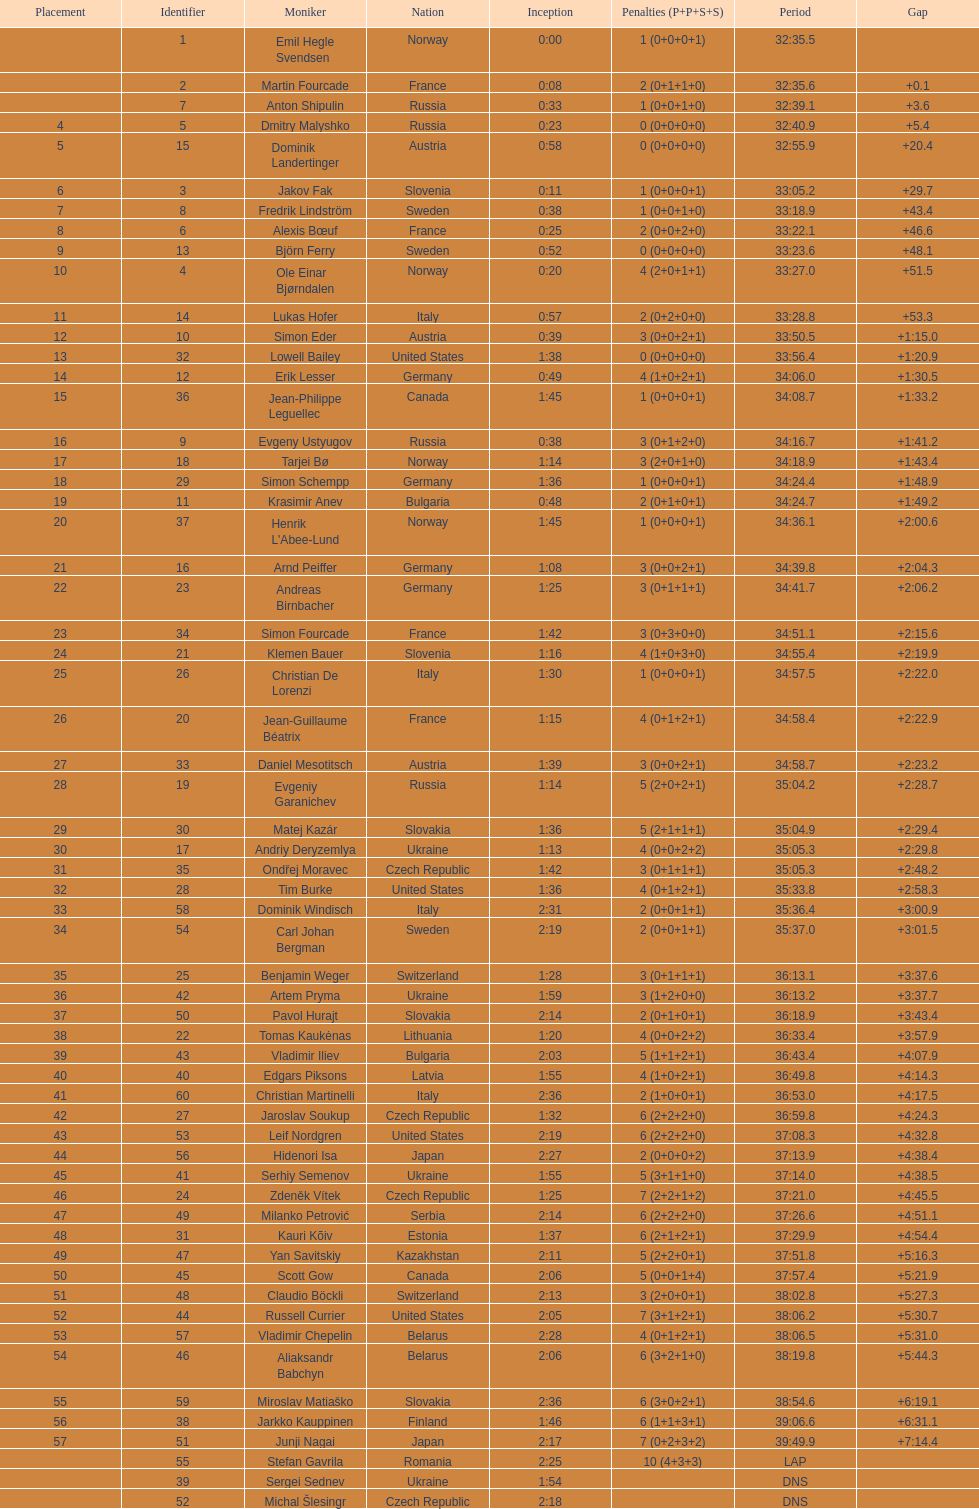Between bjorn ferry, simon elder and erik lesser - who had the most penalties? Erik Lesser. Would you be able to parse every entry in this table? {'header': ['Placement', 'Identifier', 'Moniker', 'Nation', 'Inception', 'Penalties (P+P+S+S)', 'Period', 'Gap'], 'rows': [['', '1', 'Emil Hegle Svendsen', 'Norway', '0:00', '1 (0+0+0+1)', '32:35.5', ''], ['', '2', 'Martin Fourcade', 'France', '0:08', '2 (0+1+1+0)', '32:35.6', '+0.1'], ['', '7', 'Anton Shipulin', 'Russia', '0:33', '1 (0+0+1+0)', '32:39.1', '+3.6'], ['4', '5', 'Dmitry Malyshko', 'Russia', '0:23', '0 (0+0+0+0)', '32:40.9', '+5.4'], ['5', '15', 'Dominik Landertinger', 'Austria', '0:58', '0 (0+0+0+0)', '32:55.9', '+20.4'], ['6', '3', 'Jakov Fak', 'Slovenia', '0:11', '1 (0+0+0+1)', '33:05.2', '+29.7'], ['7', '8', 'Fredrik Lindström', 'Sweden', '0:38', '1 (0+0+1+0)', '33:18.9', '+43.4'], ['8', '6', 'Alexis Bœuf', 'France', '0:25', '2 (0+0+2+0)', '33:22.1', '+46.6'], ['9', '13', 'Björn Ferry', 'Sweden', '0:52', '0 (0+0+0+0)', '33:23.6', '+48.1'], ['10', '4', 'Ole Einar Bjørndalen', 'Norway', '0:20', '4 (2+0+1+1)', '33:27.0', '+51.5'], ['11', '14', 'Lukas Hofer', 'Italy', '0:57', '2 (0+2+0+0)', '33:28.8', '+53.3'], ['12', '10', 'Simon Eder', 'Austria', '0:39', '3 (0+0+2+1)', '33:50.5', '+1:15.0'], ['13', '32', 'Lowell Bailey', 'United States', '1:38', '0 (0+0+0+0)', '33:56.4', '+1:20.9'], ['14', '12', 'Erik Lesser', 'Germany', '0:49', '4 (1+0+2+1)', '34:06.0', '+1:30.5'], ['15', '36', 'Jean-Philippe Leguellec', 'Canada', '1:45', '1 (0+0+0+1)', '34:08.7', '+1:33.2'], ['16', '9', 'Evgeny Ustyugov', 'Russia', '0:38', '3 (0+1+2+0)', '34:16.7', '+1:41.2'], ['17', '18', 'Tarjei Bø', 'Norway', '1:14', '3 (2+0+1+0)', '34:18.9', '+1:43.4'], ['18', '29', 'Simon Schempp', 'Germany', '1:36', '1 (0+0+0+1)', '34:24.4', '+1:48.9'], ['19', '11', 'Krasimir Anev', 'Bulgaria', '0:48', '2 (0+1+0+1)', '34:24.7', '+1:49.2'], ['20', '37', "Henrik L'Abee-Lund", 'Norway', '1:45', '1 (0+0+0+1)', '34:36.1', '+2:00.6'], ['21', '16', 'Arnd Peiffer', 'Germany', '1:08', '3 (0+0+2+1)', '34:39.8', '+2:04.3'], ['22', '23', 'Andreas Birnbacher', 'Germany', '1:25', '3 (0+1+1+1)', '34:41.7', '+2:06.2'], ['23', '34', 'Simon Fourcade', 'France', '1:42', '3 (0+3+0+0)', '34:51.1', '+2:15.6'], ['24', '21', 'Klemen Bauer', 'Slovenia', '1:16', '4 (1+0+3+0)', '34:55.4', '+2:19.9'], ['25', '26', 'Christian De Lorenzi', 'Italy', '1:30', '1 (0+0+0+1)', '34:57.5', '+2:22.0'], ['26', '20', 'Jean-Guillaume Béatrix', 'France', '1:15', '4 (0+1+2+1)', '34:58.4', '+2:22.9'], ['27', '33', 'Daniel Mesotitsch', 'Austria', '1:39', '3 (0+0+2+1)', '34:58.7', '+2:23.2'], ['28', '19', 'Evgeniy Garanichev', 'Russia', '1:14', '5 (2+0+2+1)', '35:04.2', '+2:28.7'], ['29', '30', 'Matej Kazár', 'Slovakia', '1:36', '5 (2+1+1+1)', '35:04.9', '+2:29.4'], ['30', '17', 'Andriy Deryzemlya', 'Ukraine', '1:13', '4 (0+0+2+2)', '35:05.3', '+2:29.8'], ['31', '35', 'Ondřej Moravec', 'Czech Republic', '1:42', '3 (0+1+1+1)', '35:05.3', '+2:48.2'], ['32', '28', 'Tim Burke', 'United States', '1:36', '4 (0+1+2+1)', '35:33.8', '+2:58.3'], ['33', '58', 'Dominik Windisch', 'Italy', '2:31', '2 (0+0+1+1)', '35:36.4', '+3:00.9'], ['34', '54', 'Carl Johan Bergman', 'Sweden', '2:19', '2 (0+0+1+1)', '35:37.0', '+3:01.5'], ['35', '25', 'Benjamin Weger', 'Switzerland', '1:28', '3 (0+1+1+1)', '36:13.1', '+3:37.6'], ['36', '42', 'Artem Pryma', 'Ukraine', '1:59', '3 (1+2+0+0)', '36:13.2', '+3:37.7'], ['37', '50', 'Pavol Hurajt', 'Slovakia', '2:14', '2 (0+1+0+1)', '36:18.9', '+3:43.4'], ['38', '22', 'Tomas Kaukėnas', 'Lithuania', '1:20', '4 (0+0+2+2)', '36:33.4', '+3:57.9'], ['39', '43', 'Vladimir Iliev', 'Bulgaria', '2:03', '5 (1+1+2+1)', '36:43.4', '+4:07.9'], ['40', '40', 'Edgars Piksons', 'Latvia', '1:55', '4 (1+0+2+1)', '36:49.8', '+4:14.3'], ['41', '60', 'Christian Martinelli', 'Italy', '2:36', '2 (1+0+0+1)', '36:53.0', '+4:17.5'], ['42', '27', 'Jaroslav Soukup', 'Czech Republic', '1:32', '6 (2+2+2+0)', '36:59.8', '+4:24.3'], ['43', '53', 'Leif Nordgren', 'United States', '2:19', '6 (2+2+2+0)', '37:08.3', '+4:32.8'], ['44', '56', 'Hidenori Isa', 'Japan', '2:27', '2 (0+0+0+2)', '37:13.9', '+4:38.4'], ['45', '41', 'Serhiy Semenov', 'Ukraine', '1:55', '5 (3+1+1+0)', '37:14.0', '+4:38.5'], ['46', '24', 'Zdeněk Vítek', 'Czech Republic', '1:25', '7 (2+2+1+2)', '37:21.0', '+4:45.5'], ['47', '49', 'Milanko Petrović', 'Serbia', '2:14', '6 (2+2+2+0)', '37:26.6', '+4:51.1'], ['48', '31', 'Kauri Kõiv', 'Estonia', '1:37', '6 (2+1+2+1)', '37:29.9', '+4:54.4'], ['49', '47', 'Yan Savitskiy', 'Kazakhstan', '2:11', '5 (2+2+0+1)', '37:51.8', '+5:16.3'], ['50', '45', 'Scott Gow', 'Canada', '2:06', '5 (0+0+1+4)', '37:57.4', '+5:21.9'], ['51', '48', 'Claudio Böckli', 'Switzerland', '2:13', '3 (2+0+0+1)', '38:02.8', '+5:27.3'], ['52', '44', 'Russell Currier', 'United States', '2:05', '7 (3+1+2+1)', '38:06.2', '+5:30.7'], ['53', '57', 'Vladimir Chepelin', 'Belarus', '2:28', '4 (0+1+2+1)', '38:06.5', '+5:31.0'], ['54', '46', 'Aliaksandr Babchyn', 'Belarus', '2:06', '6 (3+2+1+0)', '38:19.8', '+5:44.3'], ['55', '59', 'Miroslav Matiaško', 'Slovakia', '2:36', '6 (3+0+2+1)', '38:54.6', '+6:19.1'], ['56', '38', 'Jarkko Kauppinen', 'Finland', '1:46', '6 (1+1+3+1)', '39:06.6', '+6:31.1'], ['57', '51', 'Junji Nagai', 'Japan', '2:17', '7 (0+2+3+2)', '39:49.9', '+7:14.4'], ['', '55', 'Stefan Gavrila', 'Romania', '2:25', '10 (4+3+3)', 'LAP', ''], ['', '39', 'Sergei Sednev', 'Ukraine', '1:54', '', 'DNS', ''], ['', '52', 'Michal Šlesingr', 'Czech Republic', '2:18', '', 'DNS', '']]} 